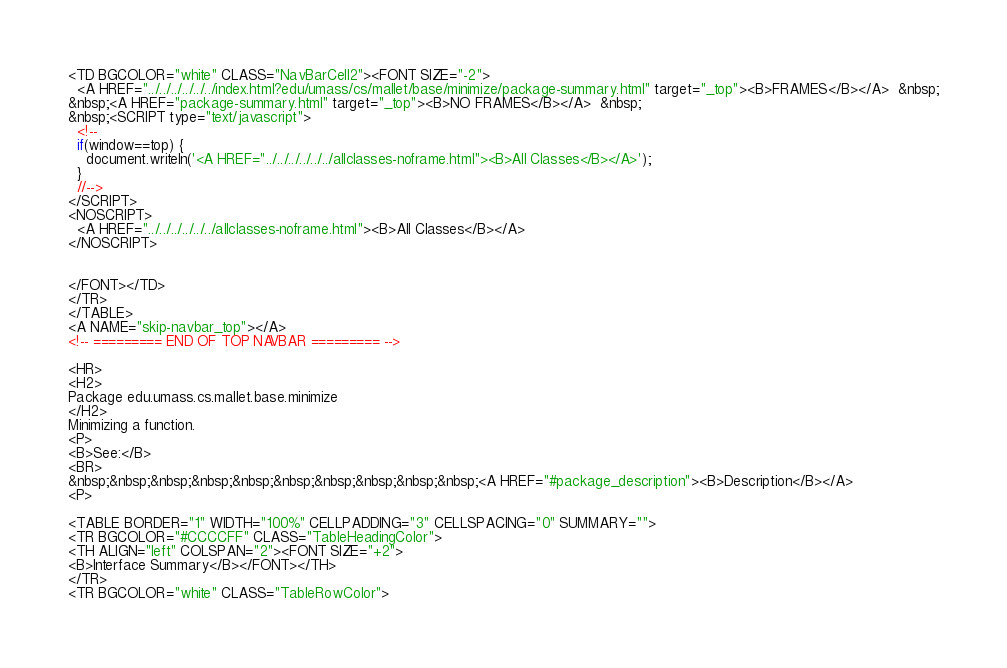<code> <loc_0><loc_0><loc_500><loc_500><_HTML_><TD BGCOLOR="white" CLASS="NavBarCell2"><FONT SIZE="-2">
  <A HREF="../../../../../../index.html?edu/umass/cs/mallet/base/minimize/package-summary.html" target="_top"><B>FRAMES</B></A>  &nbsp;
&nbsp;<A HREF="package-summary.html" target="_top"><B>NO FRAMES</B></A>  &nbsp;
&nbsp;<SCRIPT type="text/javascript">
  <!--
  if(window==top) {
    document.writeln('<A HREF="../../../../../../allclasses-noframe.html"><B>All Classes</B></A>');
  }
  //-->
</SCRIPT>
<NOSCRIPT>
  <A HREF="../../../../../../allclasses-noframe.html"><B>All Classes</B></A>
</NOSCRIPT>


</FONT></TD>
</TR>
</TABLE>
<A NAME="skip-navbar_top"></A>
<!-- ========= END OF TOP NAVBAR ========= -->

<HR>
<H2>
Package edu.umass.cs.mallet.base.minimize
</H2>
Minimizing a function.
<P>
<B>See:</B>
<BR>
&nbsp;&nbsp;&nbsp;&nbsp;&nbsp;&nbsp;&nbsp;&nbsp;&nbsp;&nbsp;<A HREF="#package_description"><B>Description</B></A>
<P>

<TABLE BORDER="1" WIDTH="100%" CELLPADDING="3" CELLSPACING="0" SUMMARY="">
<TR BGCOLOR="#CCCCFF" CLASS="TableHeadingColor">
<TH ALIGN="left" COLSPAN="2"><FONT SIZE="+2">
<B>Interface Summary</B></FONT></TH>
</TR>
<TR BGCOLOR="white" CLASS="TableRowColor"></code> 